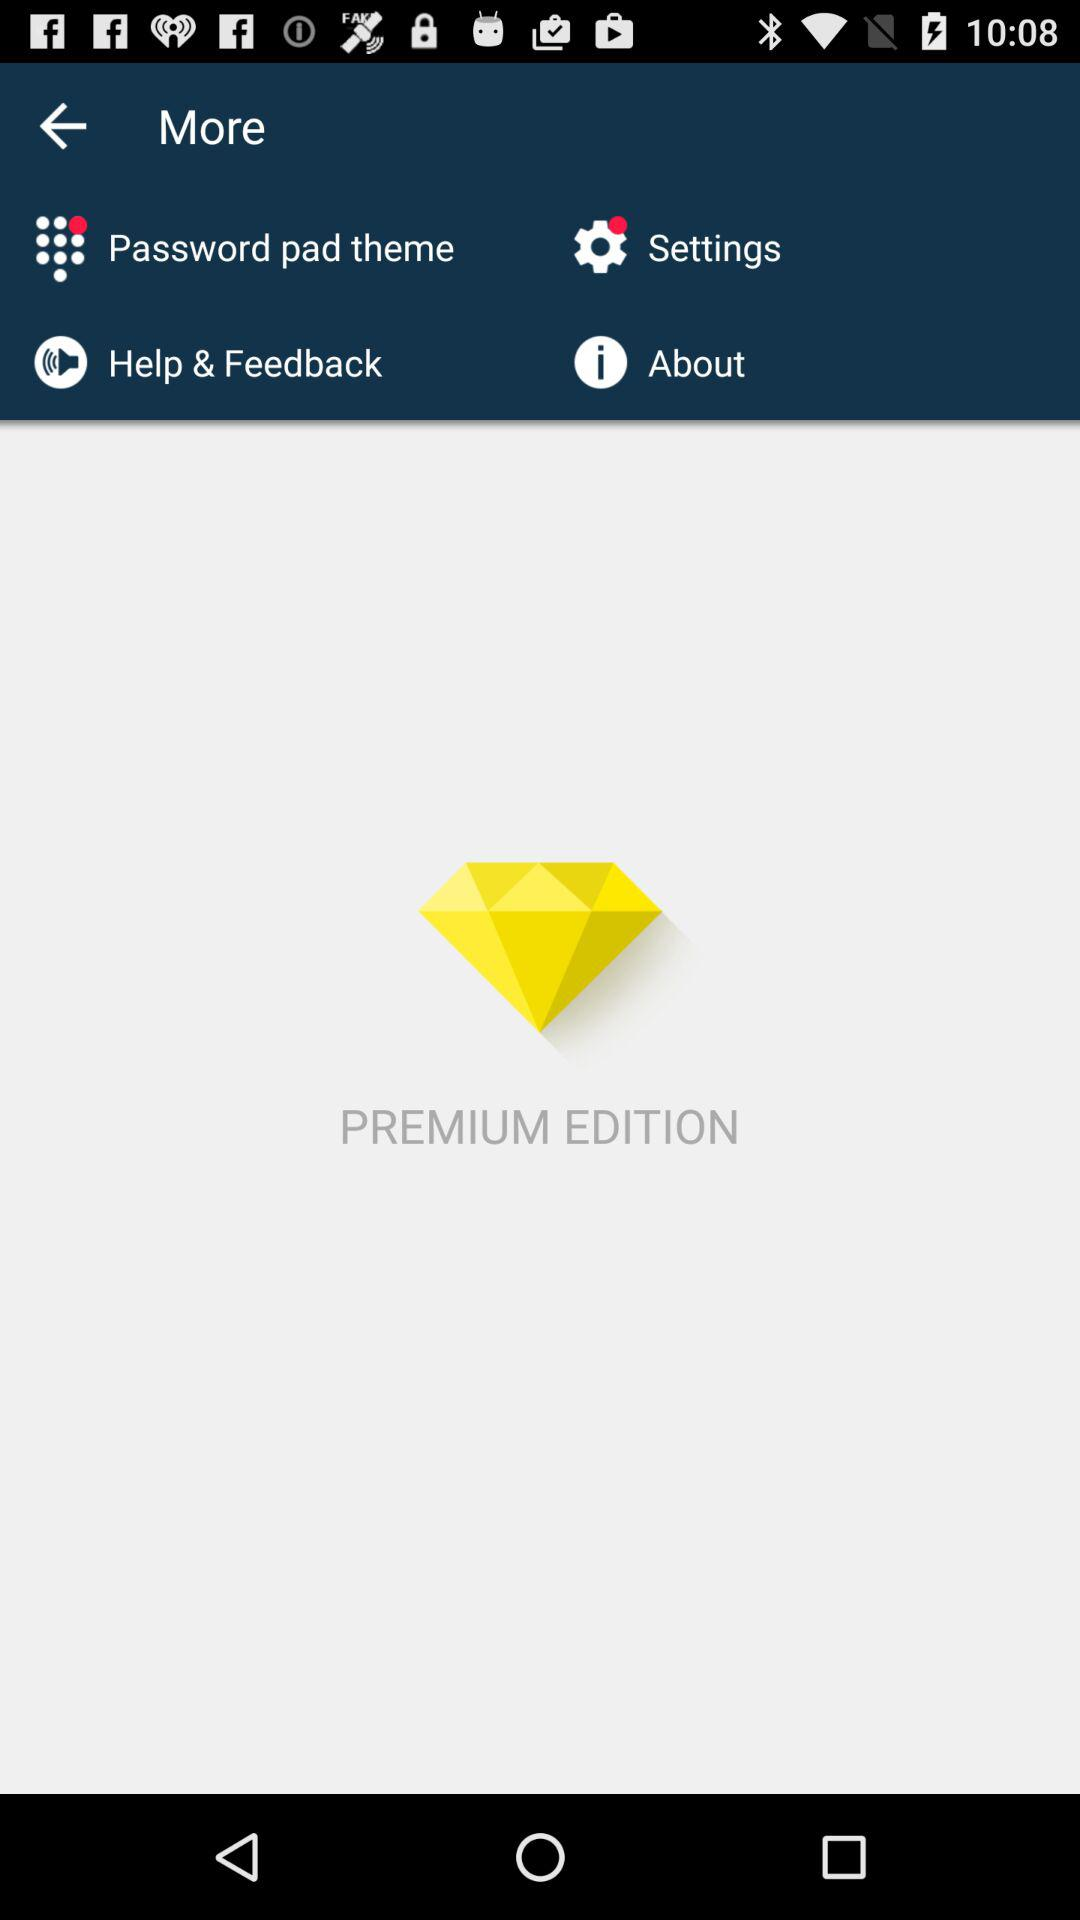What edition is it? It is the premium edition. 